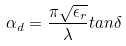<formula> <loc_0><loc_0><loc_500><loc_500>\alpha _ { d } = \frac { \pi \sqrt { \epsilon _ { r } } } { \lambda } t a n \delta</formula> 